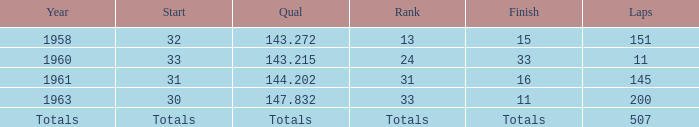What year did the finish of 15 happen in? 1958.0. 